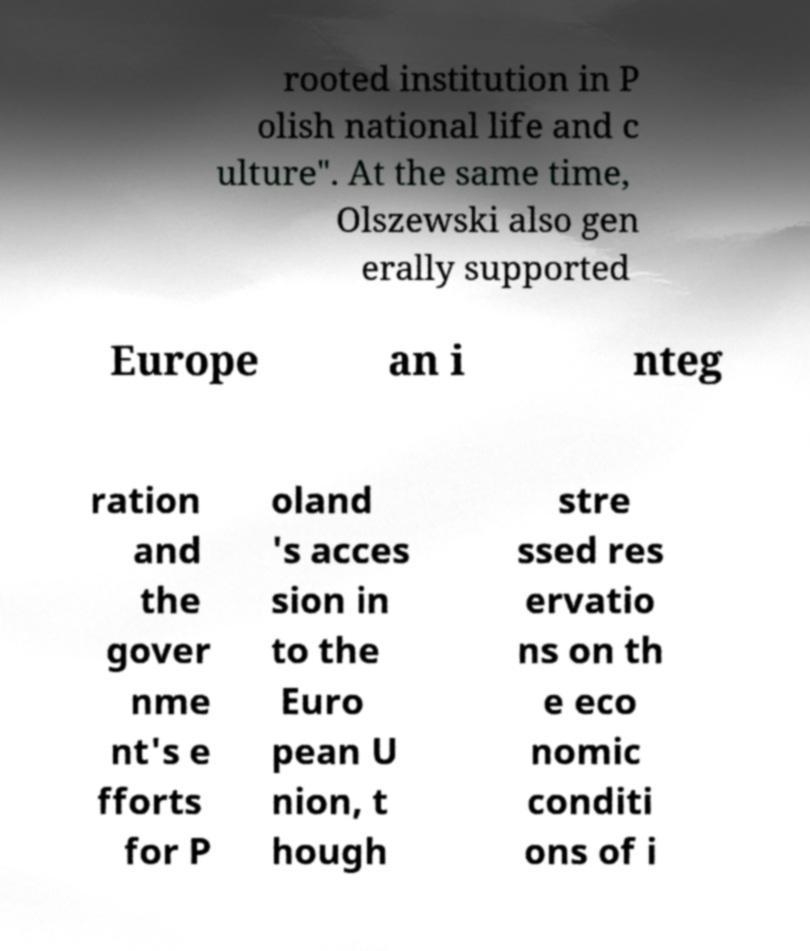Could you assist in decoding the text presented in this image and type it out clearly? rooted institution in P olish national life and c ulture". At the same time, Olszewski also gen erally supported Europe an i nteg ration and the gover nme nt's e fforts for P oland 's acces sion in to the Euro pean U nion, t hough stre ssed res ervatio ns on th e eco nomic conditi ons of i 